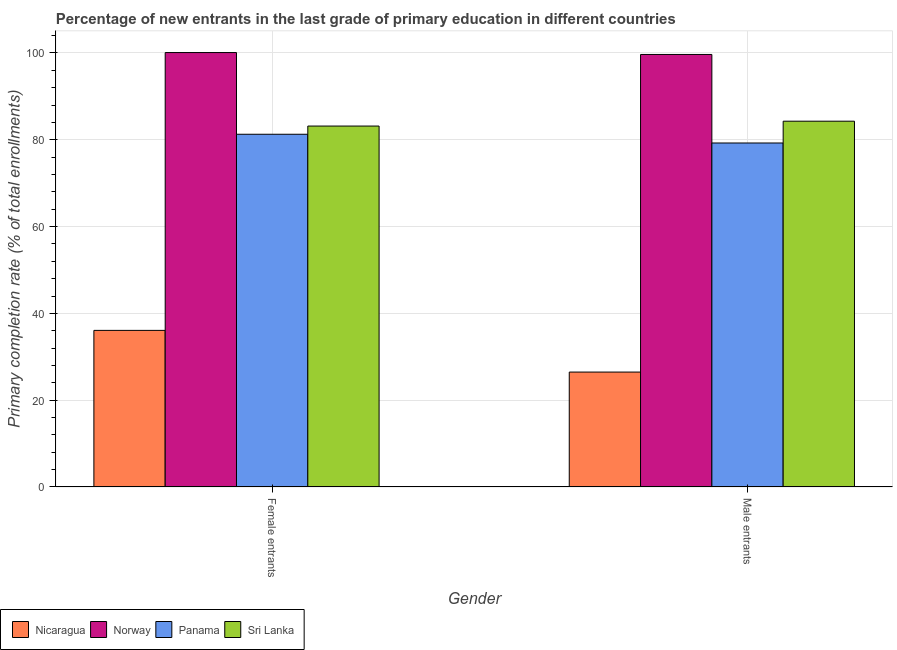How many different coloured bars are there?
Keep it short and to the point. 4. How many bars are there on the 1st tick from the left?
Provide a short and direct response. 4. What is the label of the 2nd group of bars from the left?
Make the answer very short. Male entrants. What is the primary completion rate of female entrants in Sri Lanka?
Offer a terse response. 83.16. Across all countries, what is the maximum primary completion rate of male entrants?
Make the answer very short. 99.66. Across all countries, what is the minimum primary completion rate of male entrants?
Give a very brief answer. 26.48. In which country was the primary completion rate of male entrants maximum?
Keep it short and to the point. Norway. In which country was the primary completion rate of male entrants minimum?
Offer a very short reply. Nicaragua. What is the total primary completion rate of female entrants in the graph?
Your response must be concise. 300.62. What is the difference between the primary completion rate of male entrants in Sri Lanka and that in Panama?
Give a very brief answer. 5.02. What is the difference between the primary completion rate of male entrants in Norway and the primary completion rate of female entrants in Nicaragua?
Give a very brief answer. 63.57. What is the average primary completion rate of female entrants per country?
Make the answer very short. 75.15. What is the difference between the primary completion rate of male entrants and primary completion rate of female entrants in Panama?
Your answer should be compact. -2.01. What is the ratio of the primary completion rate of female entrants in Sri Lanka to that in Norway?
Provide a short and direct response. 0.83. What does the 4th bar from the right in Female entrants represents?
Keep it short and to the point. Nicaragua. Are all the bars in the graph horizontal?
Offer a very short reply. No. How many countries are there in the graph?
Give a very brief answer. 4. What is the difference between two consecutive major ticks on the Y-axis?
Offer a terse response. 20. Are the values on the major ticks of Y-axis written in scientific E-notation?
Provide a succinct answer. No. Does the graph contain any zero values?
Ensure brevity in your answer.  No. Does the graph contain grids?
Ensure brevity in your answer.  Yes. Where does the legend appear in the graph?
Provide a succinct answer. Bottom left. How are the legend labels stacked?
Make the answer very short. Horizontal. What is the title of the graph?
Your response must be concise. Percentage of new entrants in the last grade of primary education in different countries. What is the label or title of the Y-axis?
Offer a terse response. Primary completion rate (% of total enrollments). What is the Primary completion rate (% of total enrollments) in Nicaragua in Female entrants?
Keep it short and to the point. 36.08. What is the Primary completion rate (% of total enrollments) in Norway in Female entrants?
Make the answer very short. 100.1. What is the Primary completion rate (% of total enrollments) of Panama in Female entrants?
Keep it short and to the point. 81.27. What is the Primary completion rate (% of total enrollments) in Sri Lanka in Female entrants?
Offer a terse response. 83.16. What is the Primary completion rate (% of total enrollments) of Nicaragua in Male entrants?
Keep it short and to the point. 26.48. What is the Primary completion rate (% of total enrollments) in Norway in Male entrants?
Make the answer very short. 99.66. What is the Primary completion rate (% of total enrollments) in Panama in Male entrants?
Make the answer very short. 79.26. What is the Primary completion rate (% of total enrollments) of Sri Lanka in Male entrants?
Your answer should be very brief. 84.28. Across all Gender, what is the maximum Primary completion rate (% of total enrollments) in Nicaragua?
Offer a very short reply. 36.08. Across all Gender, what is the maximum Primary completion rate (% of total enrollments) in Norway?
Your answer should be very brief. 100.1. Across all Gender, what is the maximum Primary completion rate (% of total enrollments) of Panama?
Provide a succinct answer. 81.27. Across all Gender, what is the maximum Primary completion rate (% of total enrollments) of Sri Lanka?
Ensure brevity in your answer.  84.28. Across all Gender, what is the minimum Primary completion rate (% of total enrollments) in Nicaragua?
Ensure brevity in your answer.  26.48. Across all Gender, what is the minimum Primary completion rate (% of total enrollments) in Norway?
Ensure brevity in your answer.  99.66. Across all Gender, what is the minimum Primary completion rate (% of total enrollments) of Panama?
Your answer should be compact. 79.26. Across all Gender, what is the minimum Primary completion rate (% of total enrollments) in Sri Lanka?
Ensure brevity in your answer.  83.16. What is the total Primary completion rate (% of total enrollments) in Nicaragua in the graph?
Your answer should be very brief. 62.56. What is the total Primary completion rate (% of total enrollments) of Norway in the graph?
Your response must be concise. 199.76. What is the total Primary completion rate (% of total enrollments) in Panama in the graph?
Your answer should be very brief. 160.53. What is the total Primary completion rate (% of total enrollments) in Sri Lanka in the graph?
Offer a very short reply. 167.44. What is the difference between the Primary completion rate (% of total enrollments) of Nicaragua in Female entrants and that in Male entrants?
Ensure brevity in your answer.  9.61. What is the difference between the Primary completion rate (% of total enrollments) in Norway in Female entrants and that in Male entrants?
Provide a succinct answer. 0.44. What is the difference between the Primary completion rate (% of total enrollments) of Panama in Female entrants and that in Male entrants?
Give a very brief answer. 2.01. What is the difference between the Primary completion rate (% of total enrollments) in Sri Lanka in Female entrants and that in Male entrants?
Keep it short and to the point. -1.12. What is the difference between the Primary completion rate (% of total enrollments) of Nicaragua in Female entrants and the Primary completion rate (% of total enrollments) of Norway in Male entrants?
Offer a terse response. -63.57. What is the difference between the Primary completion rate (% of total enrollments) in Nicaragua in Female entrants and the Primary completion rate (% of total enrollments) in Panama in Male entrants?
Offer a very short reply. -43.18. What is the difference between the Primary completion rate (% of total enrollments) of Nicaragua in Female entrants and the Primary completion rate (% of total enrollments) of Sri Lanka in Male entrants?
Your response must be concise. -48.2. What is the difference between the Primary completion rate (% of total enrollments) in Norway in Female entrants and the Primary completion rate (% of total enrollments) in Panama in Male entrants?
Your response must be concise. 20.84. What is the difference between the Primary completion rate (% of total enrollments) in Norway in Female entrants and the Primary completion rate (% of total enrollments) in Sri Lanka in Male entrants?
Your answer should be compact. 15.82. What is the difference between the Primary completion rate (% of total enrollments) of Panama in Female entrants and the Primary completion rate (% of total enrollments) of Sri Lanka in Male entrants?
Your answer should be very brief. -3.01. What is the average Primary completion rate (% of total enrollments) in Nicaragua per Gender?
Give a very brief answer. 31.28. What is the average Primary completion rate (% of total enrollments) of Norway per Gender?
Make the answer very short. 99.88. What is the average Primary completion rate (% of total enrollments) of Panama per Gender?
Your answer should be compact. 80.27. What is the average Primary completion rate (% of total enrollments) of Sri Lanka per Gender?
Ensure brevity in your answer.  83.72. What is the difference between the Primary completion rate (% of total enrollments) of Nicaragua and Primary completion rate (% of total enrollments) of Norway in Female entrants?
Give a very brief answer. -64.01. What is the difference between the Primary completion rate (% of total enrollments) of Nicaragua and Primary completion rate (% of total enrollments) of Panama in Female entrants?
Make the answer very short. -45.19. What is the difference between the Primary completion rate (% of total enrollments) of Nicaragua and Primary completion rate (% of total enrollments) of Sri Lanka in Female entrants?
Give a very brief answer. -47.08. What is the difference between the Primary completion rate (% of total enrollments) of Norway and Primary completion rate (% of total enrollments) of Panama in Female entrants?
Your response must be concise. 18.83. What is the difference between the Primary completion rate (% of total enrollments) of Norway and Primary completion rate (% of total enrollments) of Sri Lanka in Female entrants?
Offer a terse response. 16.94. What is the difference between the Primary completion rate (% of total enrollments) in Panama and Primary completion rate (% of total enrollments) in Sri Lanka in Female entrants?
Offer a terse response. -1.89. What is the difference between the Primary completion rate (% of total enrollments) of Nicaragua and Primary completion rate (% of total enrollments) of Norway in Male entrants?
Provide a succinct answer. -73.18. What is the difference between the Primary completion rate (% of total enrollments) in Nicaragua and Primary completion rate (% of total enrollments) in Panama in Male entrants?
Keep it short and to the point. -52.78. What is the difference between the Primary completion rate (% of total enrollments) in Nicaragua and Primary completion rate (% of total enrollments) in Sri Lanka in Male entrants?
Make the answer very short. -57.8. What is the difference between the Primary completion rate (% of total enrollments) in Norway and Primary completion rate (% of total enrollments) in Panama in Male entrants?
Offer a terse response. 20.4. What is the difference between the Primary completion rate (% of total enrollments) in Norway and Primary completion rate (% of total enrollments) in Sri Lanka in Male entrants?
Keep it short and to the point. 15.38. What is the difference between the Primary completion rate (% of total enrollments) in Panama and Primary completion rate (% of total enrollments) in Sri Lanka in Male entrants?
Offer a very short reply. -5.02. What is the ratio of the Primary completion rate (% of total enrollments) in Nicaragua in Female entrants to that in Male entrants?
Your response must be concise. 1.36. What is the ratio of the Primary completion rate (% of total enrollments) of Panama in Female entrants to that in Male entrants?
Offer a terse response. 1.03. What is the ratio of the Primary completion rate (% of total enrollments) of Sri Lanka in Female entrants to that in Male entrants?
Provide a succinct answer. 0.99. What is the difference between the highest and the second highest Primary completion rate (% of total enrollments) of Nicaragua?
Give a very brief answer. 9.61. What is the difference between the highest and the second highest Primary completion rate (% of total enrollments) in Norway?
Provide a short and direct response. 0.44. What is the difference between the highest and the second highest Primary completion rate (% of total enrollments) of Panama?
Provide a succinct answer. 2.01. What is the difference between the highest and the second highest Primary completion rate (% of total enrollments) of Sri Lanka?
Your response must be concise. 1.12. What is the difference between the highest and the lowest Primary completion rate (% of total enrollments) of Nicaragua?
Your response must be concise. 9.61. What is the difference between the highest and the lowest Primary completion rate (% of total enrollments) of Norway?
Your response must be concise. 0.44. What is the difference between the highest and the lowest Primary completion rate (% of total enrollments) of Panama?
Provide a short and direct response. 2.01. What is the difference between the highest and the lowest Primary completion rate (% of total enrollments) in Sri Lanka?
Provide a short and direct response. 1.12. 